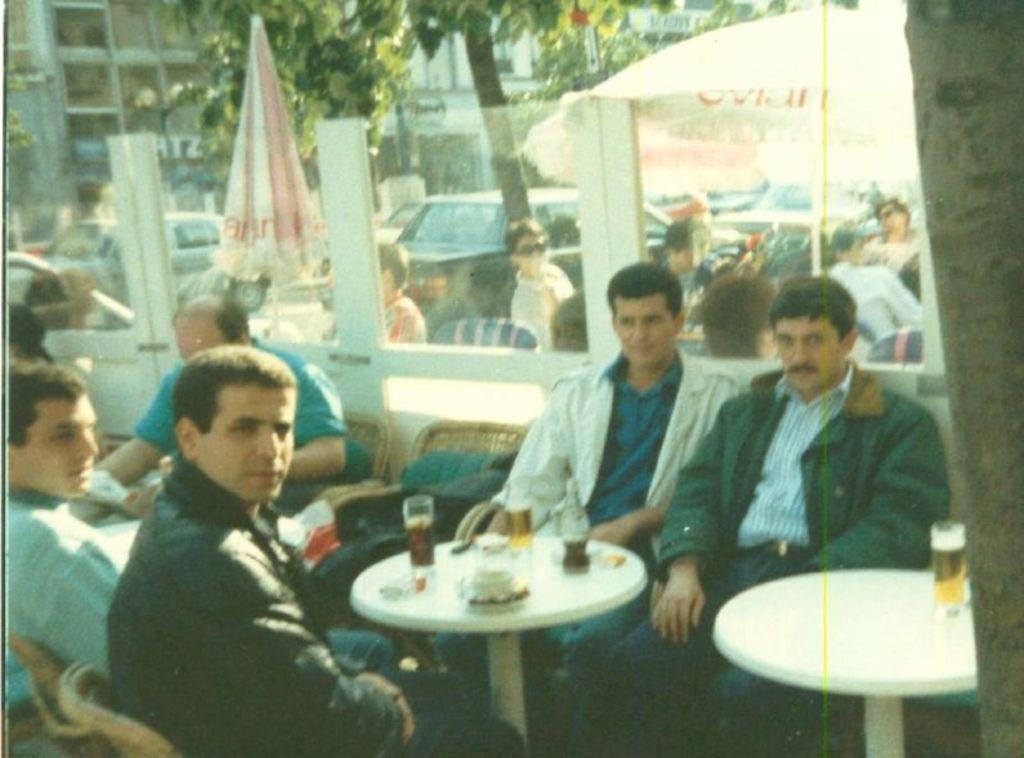Could you give a brief overview of what you see in this image? In this image we can see people sitting on the chairs near table. In the background we can see umbrellas, cars, buildings and trees. 